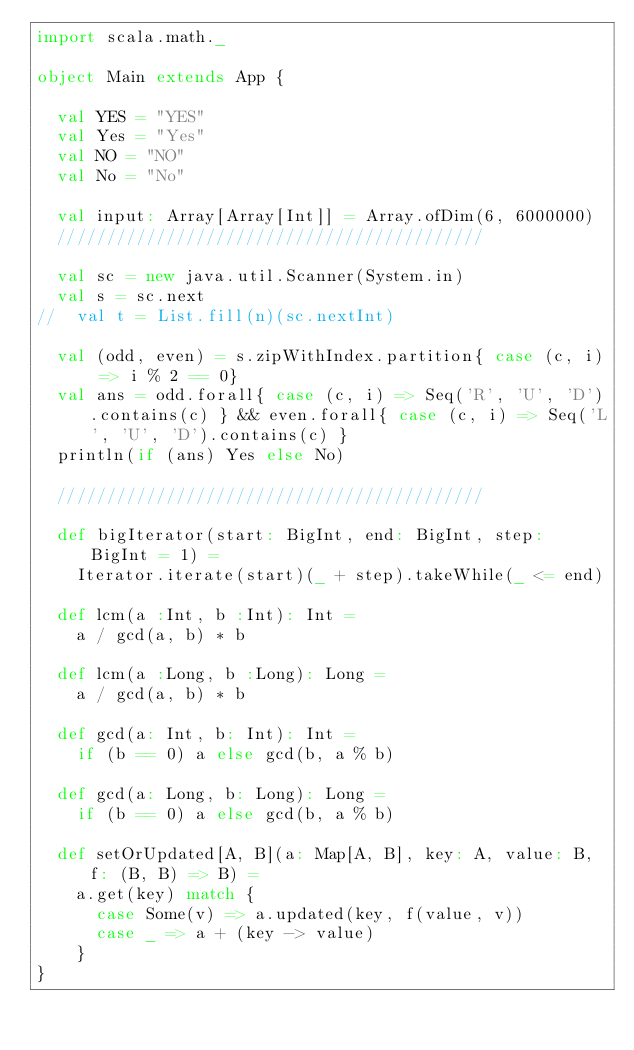Convert code to text. <code><loc_0><loc_0><loc_500><loc_500><_Scala_>import scala.math._

object Main extends App {

  val YES = "YES"
  val Yes = "Yes"
  val NO = "NO"
  val No = "No"

  val input: Array[Array[Int]] = Array.ofDim(6, 6000000)
  ///////////////////////////////////////////

  val sc = new java.util.Scanner(System.in)
  val s = sc.next
//  val t = List.fill(n)(sc.nextInt)

  val (odd, even) = s.zipWithIndex.partition{ case (c, i) => i % 2 == 0}
  val ans = odd.forall{ case (c, i) => Seq('R', 'U', 'D').contains(c) } && even.forall{ case (c, i) => Seq('L', 'U', 'D').contains(c) }
  println(if (ans) Yes else No)

  ///////////////////////////////////////////

  def bigIterator(start: BigInt, end: BigInt, step: BigInt = 1) =
    Iterator.iterate(start)(_ + step).takeWhile(_ <= end)

  def lcm(a :Int, b :Int): Int =
    a / gcd(a, b) * b

  def lcm(a :Long, b :Long): Long =
    a / gcd(a, b) * b

  def gcd(a: Int, b: Int): Int =
    if (b == 0) a else gcd(b, a % b)

  def gcd(a: Long, b: Long): Long =
    if (b == 0) a else gcd(b, a % b)

  def setOrUpdated[A, B](a: Map[A, B], key: A, value: B, f: (B, B) => B) =
    a.get(key) match {
      case Some(v) => a.updated(key, f(value, v))
      case _ => a + (key -> value)
    }
}</code> 